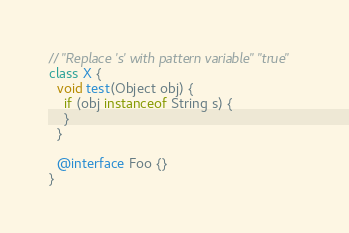Convert code to text. <code><loc_0><loc_0><loc_500><loc_500><_Java_>// "Replace 's' with pattern variable" "true"
class X {
  void test(Object obj) {
    if (obj instanceof String s) {
    }
  }
  
  @interface Foo {}
}</code> 